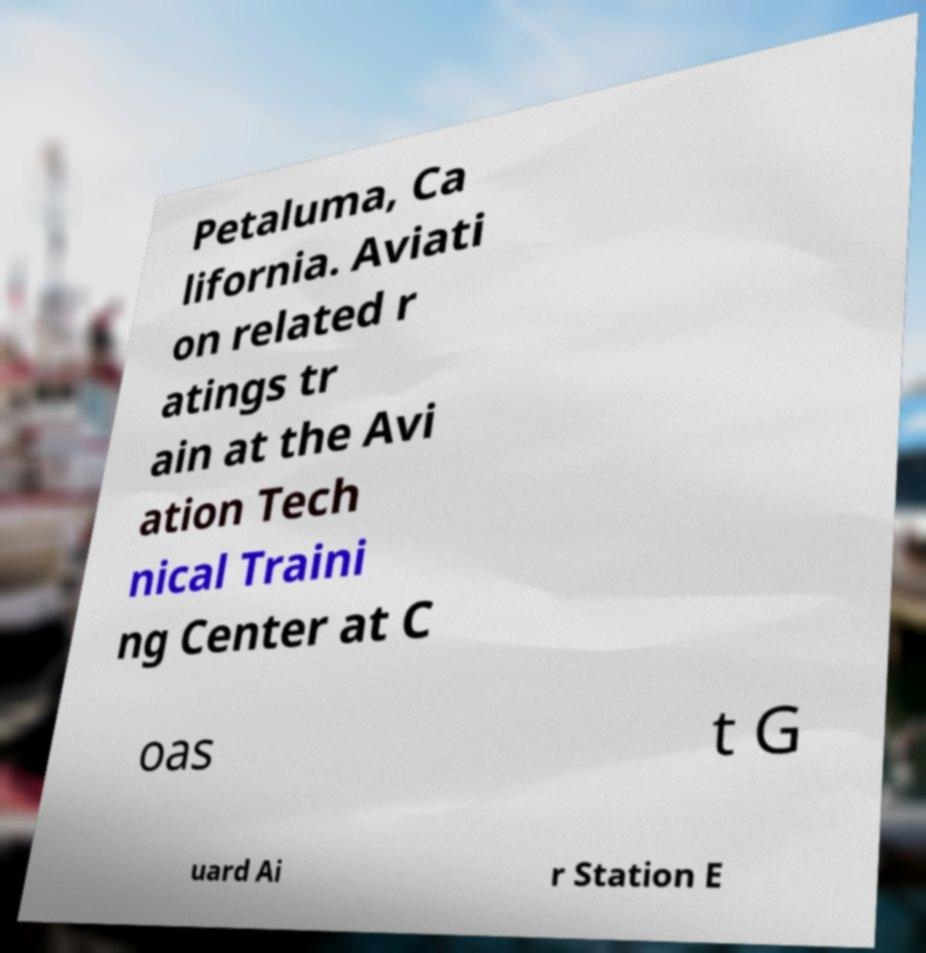Please read and relay the text visible in this image. What does it say? Petaluma, Ca lifornia. Aviati on related r atings tr ain at the Avi ation Tech nical Traini ng Center at C oas t G uard Ai r Station E 